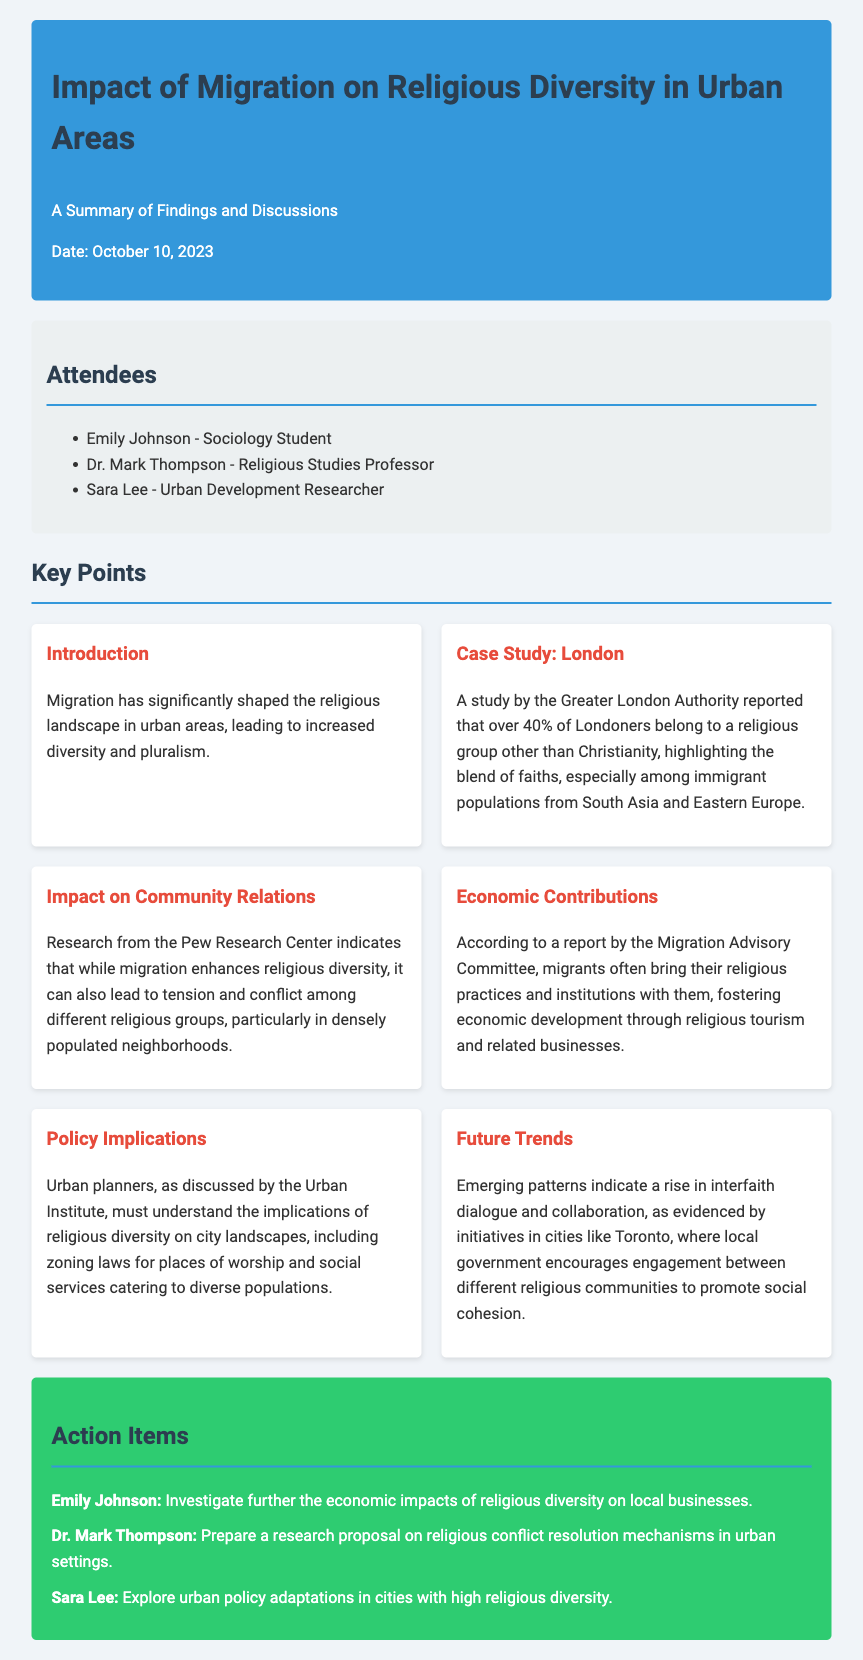what is the date of the meeting? The date of the meeting is explicitly mentioned at the beginning of the document.
Answer: October 10, 2023 who is the sociology student listed in the attendees? The attendees section lists the names and titles of participants in the meeting.
Answer: Emily Johnson what percentage of Londoners belong to a religious group other than Christianity? This percentage is stated in the case study that discusses London and its religious demographics.
Answer: over 40% which organization reported economic development due to migrants' religious practices? This information can be found in the section discussing the economic contributions of migrants.
Answer: Migration Advisory Committee what are urban planners encouraged to understand according to the policy implications? This is detailed in the policy implications section discussing the impact of religious diversity on planning.
Answer: implications of religious diversity on city landscapes what trend is evidenced by initiatives in cities like Toronto? The last section outlines emerging patterns related to interfaith relations in urban areas.
Answer: rise in interfaith dialogue and collaboration 